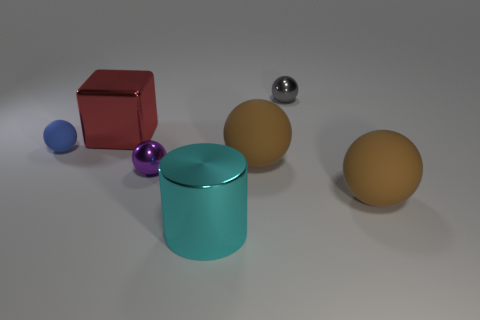Subtract all big balls. How many balls are left? 3 Add 2 large cylinders. How many objects exist? 9 Subtract all purple spheres. How many spheres are left? 4 Subtract all purple cylinders. How many brown balls are left? 2 Subtract 1 cylinders. How many cylinders are left? 0 Subtract all cyan balls. Subtract all yellow cubes. How many balls are left? 5 Subtract 0 purple cubes. How many objects are left? 7 Subtract all cylinders. How many objects are left? 6 Subtract all blocks. Subtract all purple balls. How many objects are left? 5 Add 6 red objects. How many red objects are left? 7 